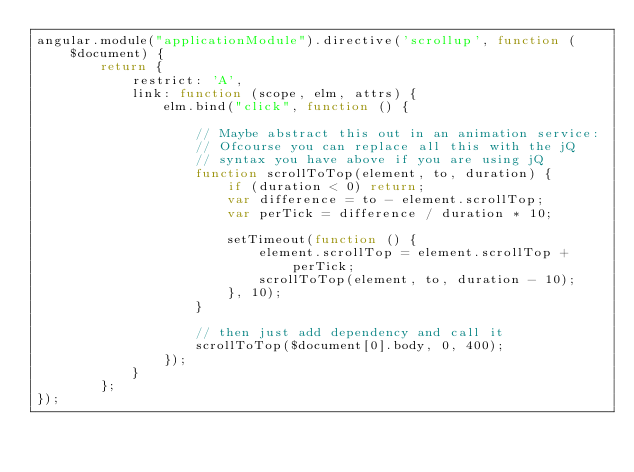<code> <loc_0><loc_0><loc_500><loc_500><_JavaScript_>angular.module("applicationModule").directive('scrollup', function ($document) {
        return {
            restrict: 'A',
            link: function (scope, elm, attrs) {
                elm.bind("click", function () {

                    // Maybe abstract this out in an animation service:
                    // Ofcourse you can replace all this with the jQ 
                    // syntax you have above if you are using jQ
                    function scrollToTop(element, to, duration) {
                        if (duration < 0) return;
                        var difference = to - element.scrollTop;
                        var perTick = difference / duration * 10;

                        setTimeout(function () {
                            element.scrollTop = element.scrollTop + perTick;
                            scrollToTop(element, to, duration - 10);
                        }, 10);
                    }

                    // then just add dependency and call it
                    scrollToTop($document[0].body, 0, 400);
                });
            }
        };
});</code> 